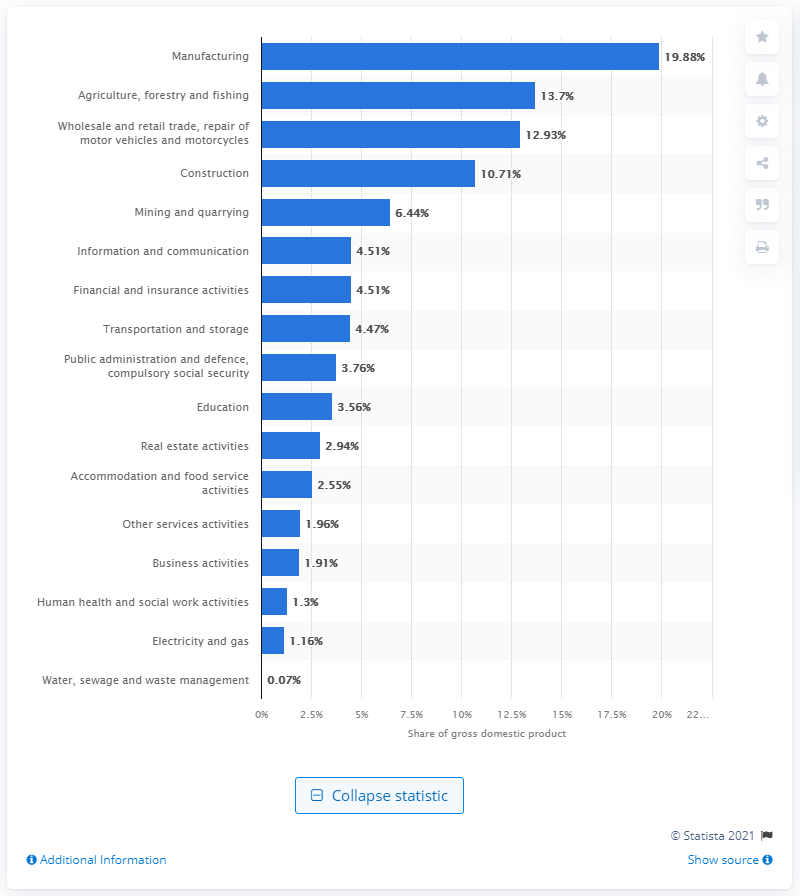Mention a couple of crucial points in this snapshot. In 2020, the manufacturing sector contributed approximately 19.88% of Indonesia's Gross Domestic Product (GDP). 